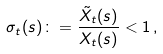Convert formula to latex. <formula><loc_0><loc_0><loc_500><loc_500>\sigma _ { t } ( s ) \colon = \frac { \tilde { X } _ { t } ( s ) } { X _ { t } ( s ) } < 1 \, ,</formula> 